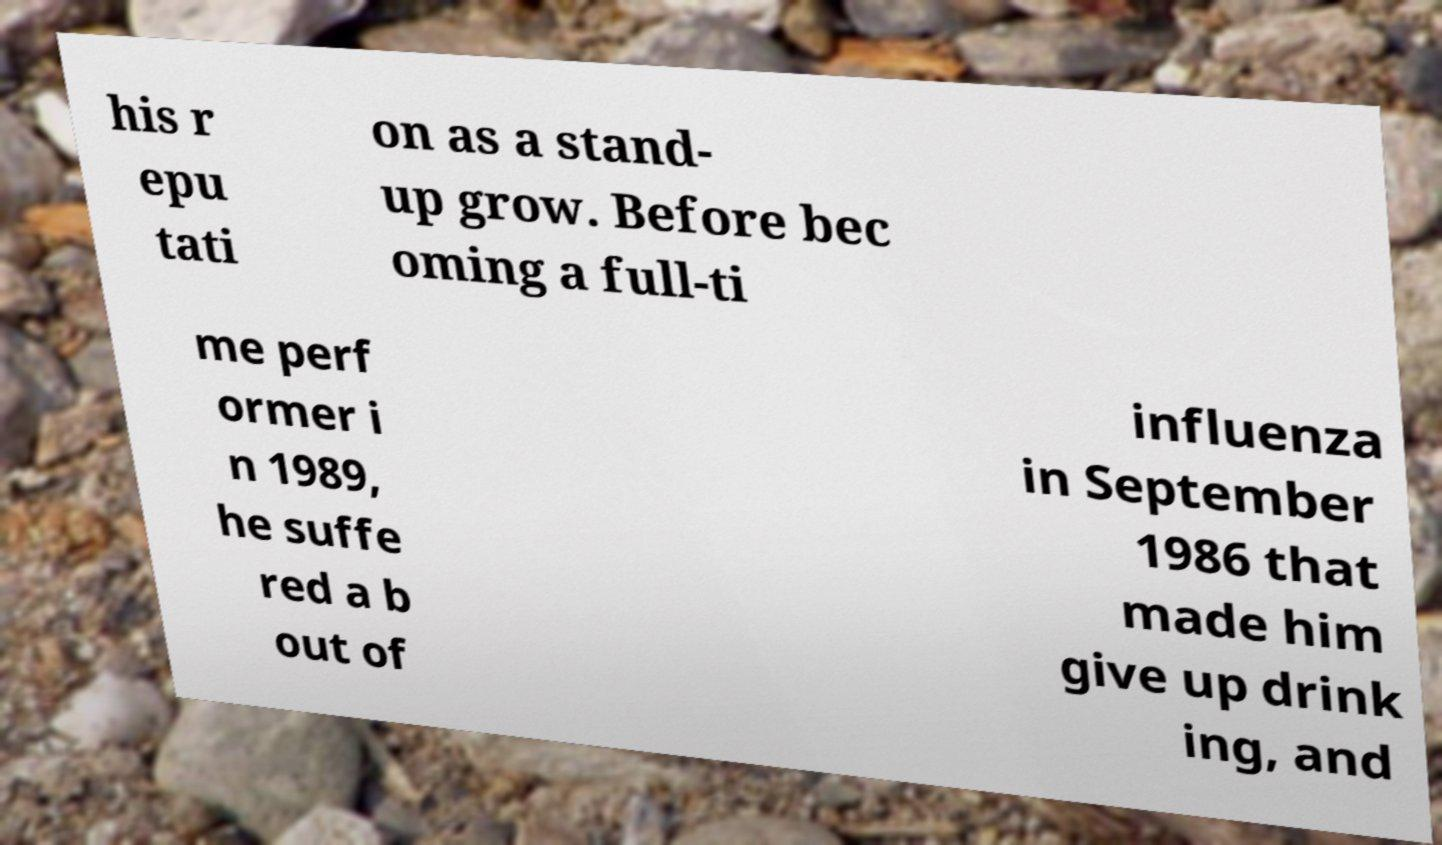For documentation purposes, I need the text within this image transcribed. Could you provide that? his r epu tati on as a stand- up grow. Before bec oming a full-ti me perf ormer i n 1989, he suffe red a b out of influenza in September 1986 that made him give up drink ing, and 